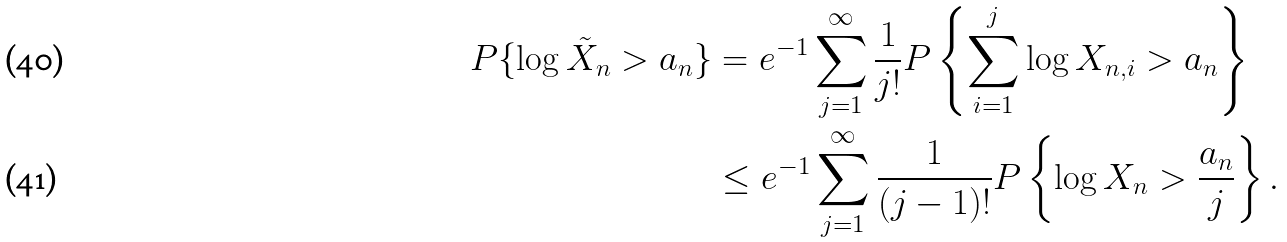<formula> <loc_0><loc_0><loc_500><loc_500>P \{ \log \tilde { X } _ { n } > a _ { n } \} & = e ^ { - 1 } \sum _ { j = 1 } ^ { \infty } \frac { 1 } { j ! } P \left \{ \sum _ { i = 1 } ^ { j } \log X _ { n , i } > a _ { n } \right \} \\ & \leq e ^ { - 1 } \sum _ { j = 1 } ^ { \infty } \frac { 1 } { ( j - 1 ) ! } P \left \{ \log X _ { n } > \frac { a _ { n } } { j } \right \} .</formula> 